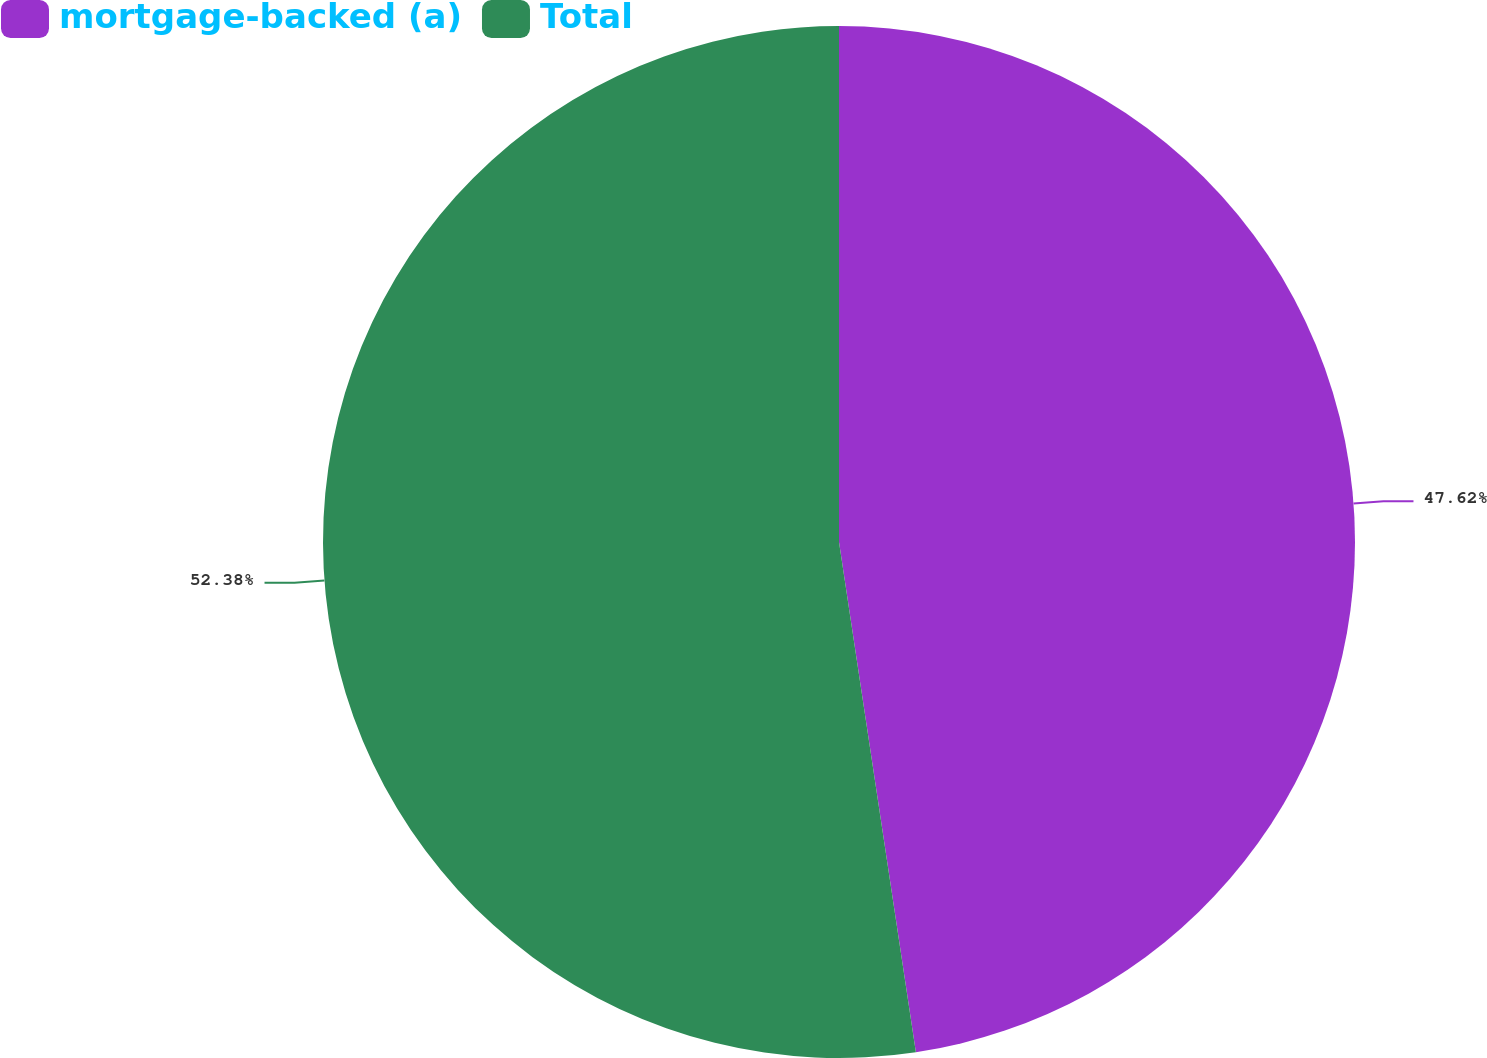<chart> <loc_0><loc_0><loc_500><loc_500><pie_chart><fcel>mortgage-backed (a)<fcel>Total<nl><fcel>47.62%<fcel>52.38%<nl></chart> 